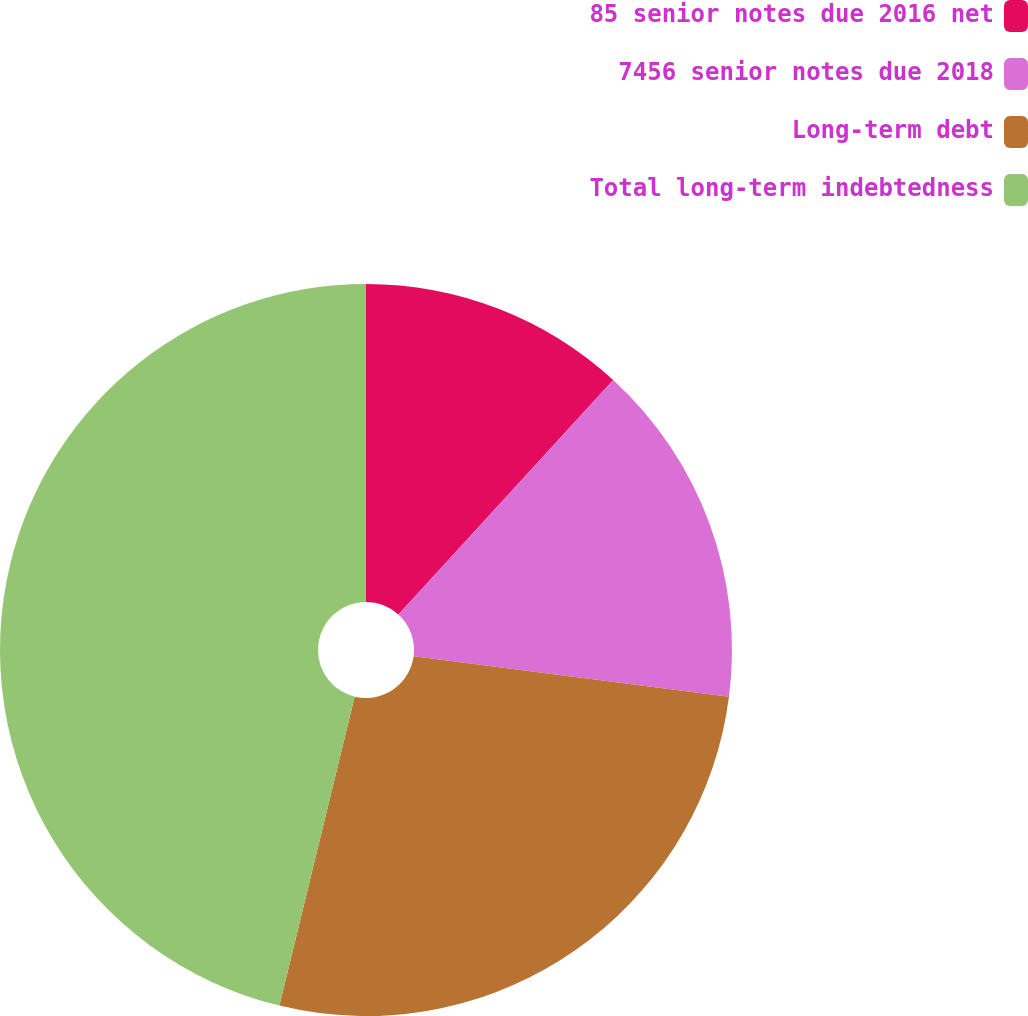Convert chart to OTSL. <chart><loc_0><loc_0><loc_500><loc_500><pie_chart><fcel>85 senior notes due 2016 net<fcel>7456 senior notes due 2018<fcel>Long-term debt<fcel>Total long-term indebtedness<nl><fcel>11.8%<fcel>15.24%<fcel>26.76%<fcel>46.2%<nl></chart> 